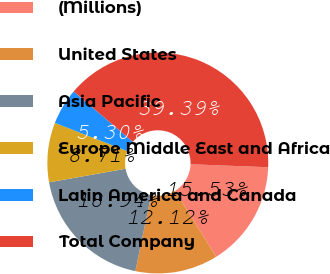Convert chart. <chart><loc_0><loc_0><loc_500><loc_500><pie_chart><fcel>(Millions)<fcel>United States<fcel>Asia Pacific<fcel>Europe Middle East and Africa<fcel>Latin America and Canada<fcel>Total Company<nl><fcel>15.53%<fcel>12.12%<fcel>18.94%<fcel>8.71%<fcel>5.3%<fcel>39.39%<nl></chart> 